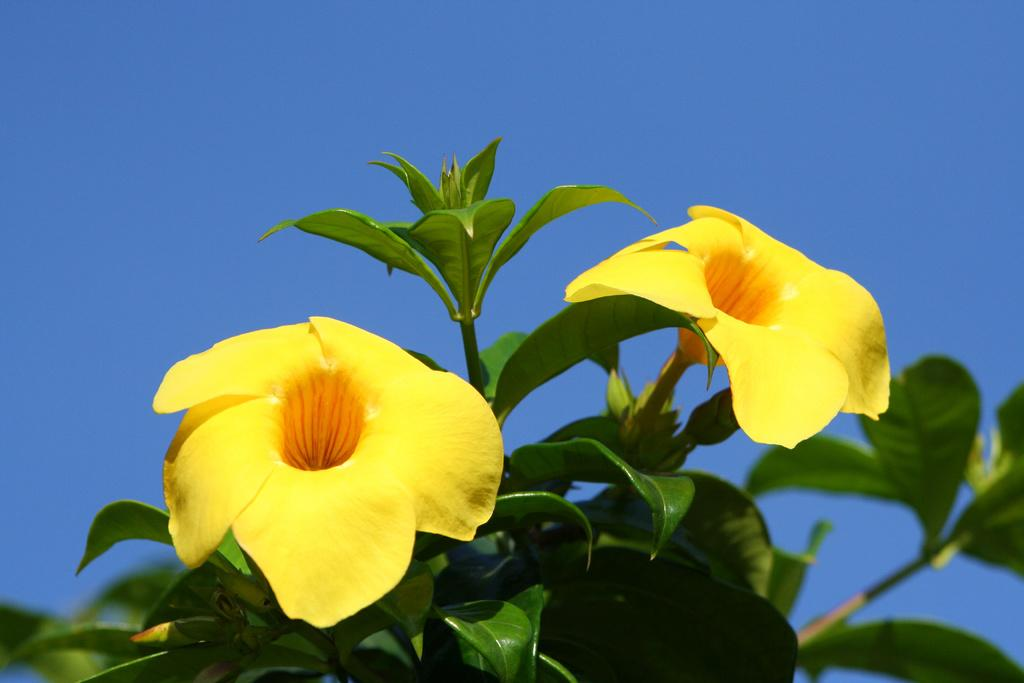What type of flower can be seen on a tree in the image? There is a yellow flower on a tree in the image. What can be seen in the background of the image? The sky is visible in the background of the image. In which drawer can the flower be found in the image? The image does not show a drawer, so the flower cannot be found in one. 